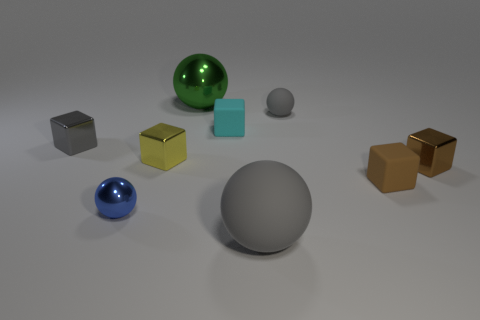Subtract all gray cubes. How many cubes are left? 4 Subtract all tiny metal spheres. How many spheres are left? 3 Subtract all purple blocks. Subtract all blue cylinders. How many blocks are left? 5 Subtract all spheres. How many objects are left? 5 Add 1 small cyan rubber cubes. How many objects exist? 10 Add 4 brown objects. How many brown objects are left? 6 Add 5 tiny gray cubes. How many tiny gray cubes exist? 6 Subtract 1 brown blocks. How many objects are left? 8 Subtract all small gray metallic cubes. Subtract all blue balls. How many objects are left? 7 